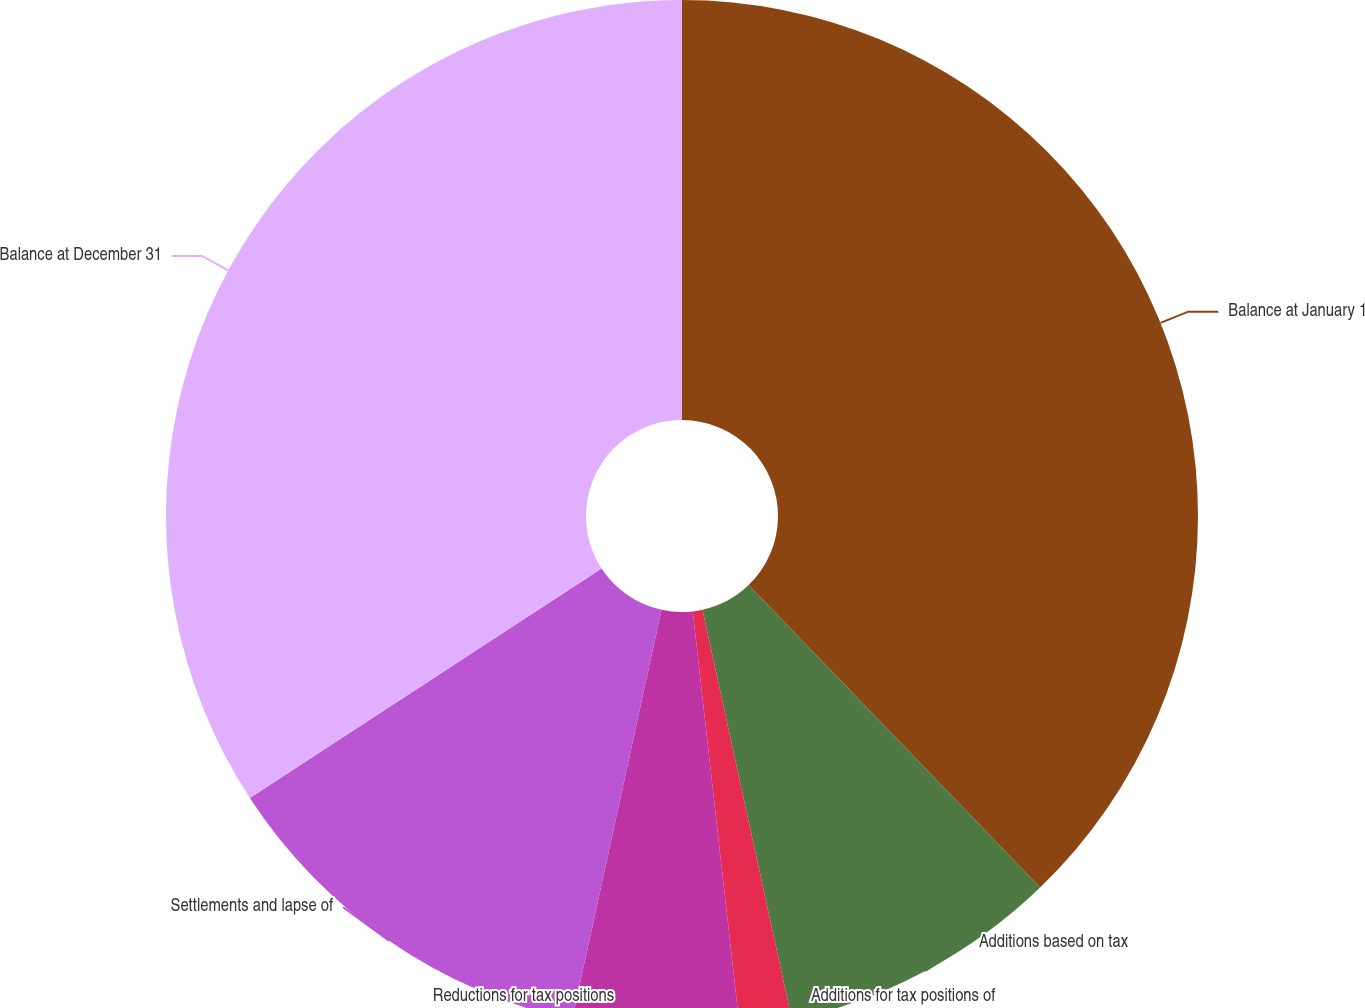Convert chart to OTSL. <chart><loc_0><loc_0><loc_500><loc_500><pie_chart><fcel>Balance at January 1<fcel>Additions based on tax<fcel>Additions for tax positions of<fcel>Reductions for tax positions<fcel>Settlements and lapse of<fcel>Balance at December 31<nl><fcel>37.79%<fcel>8.79%<fcel>1.63%<fcel>5.21%<fcel>12.38%<fcel>34.2%<nl></chart> 